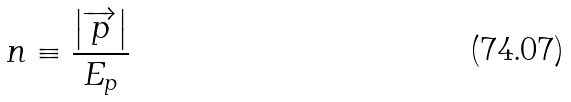Convert formula to latex. <formula><loc_0><loc_0><loc_500><loc_500>n \equiv \frac { \left | \overrightarrow { p } \right | } { E _ { p } }</formula> 